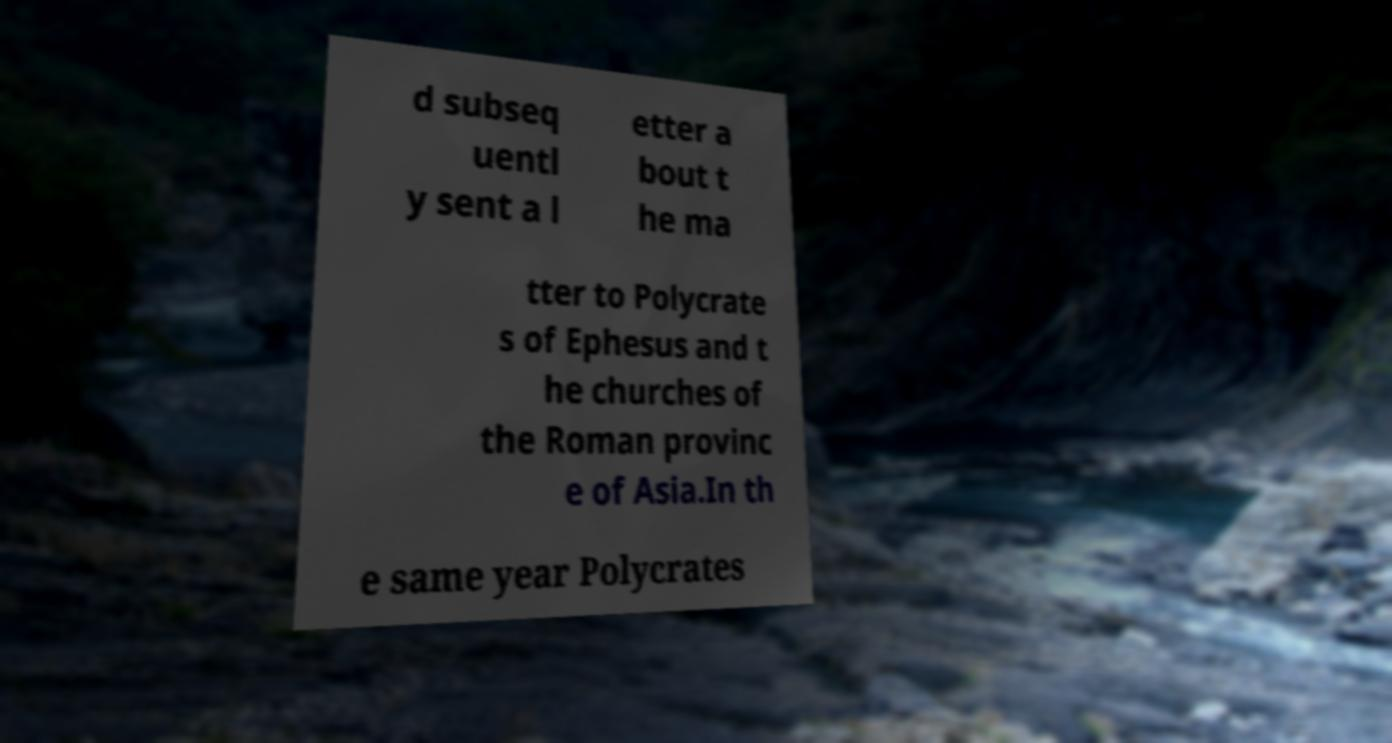What messages or text are displayed in this image? I need them in a readable, typed format. d subseq uentl y sent a l etter a bout t he ma tter to Polycrate s of Ephesus and t he churches of the Roman provinc e of Asia.In th e same year Polycrates 